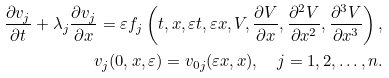<formula> <loc_0><loc_0><loc_500><loc_500>\frac { \partial v _ { j } } { \partial t } + \lambda _ { j } \frac { \partial v _ { j } } { \partial x } = \varepsilon f _ { j } \left ( t , x , \varepsilon t , \varepsilon x , V , \frac { \partial V } { \partial x } , \frac { \partial ^ { 2 } V } { \partial x ^ { 2 } } , \frac { \partial ^ { 3 } V } { \partial x ^ { 3 } } \right ) , \\ v _ { j } ( 0 , x , \varepsilon ) = v _ { 0 j } ( \varepsilon x , x ) , \quad j = 1 , 2 , \dots , n .</formula> 